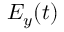Convert formula to latex. <formula><loc_0><loc_0><loc_500><loc_500>E _ { y } ( t )</formula> 